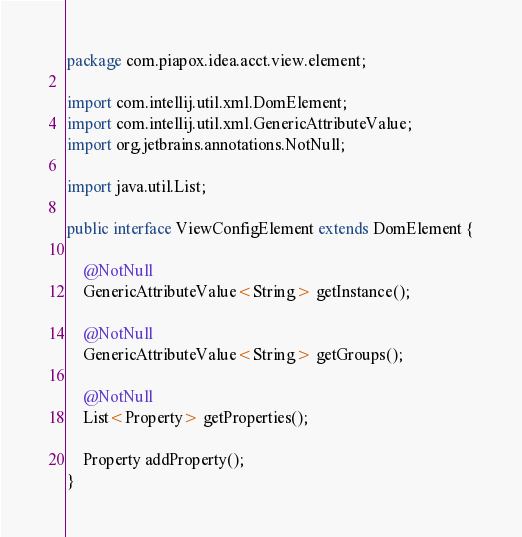Convert code to text. <code><loc_0><loc_0><loc_500><loc_500><_Java_>package com.piapox.idea.acct.view.element;

import com.intellij.util.xml.DomElement;
import com.intellij.util.xml.GenericAttributeValue;
import org.jetbrains.annotations.NotNull;

import java.util.List;

public interface ViewConfigElement extends DomElement {

    @NotNull
    GenericAttributeValue<String> getInstance();

    @NotNull
    GenericAttributeValue<String> getGroups();

    @NotNull
    List<Property> getProperties();

    Property addProperty();
}
</code> 